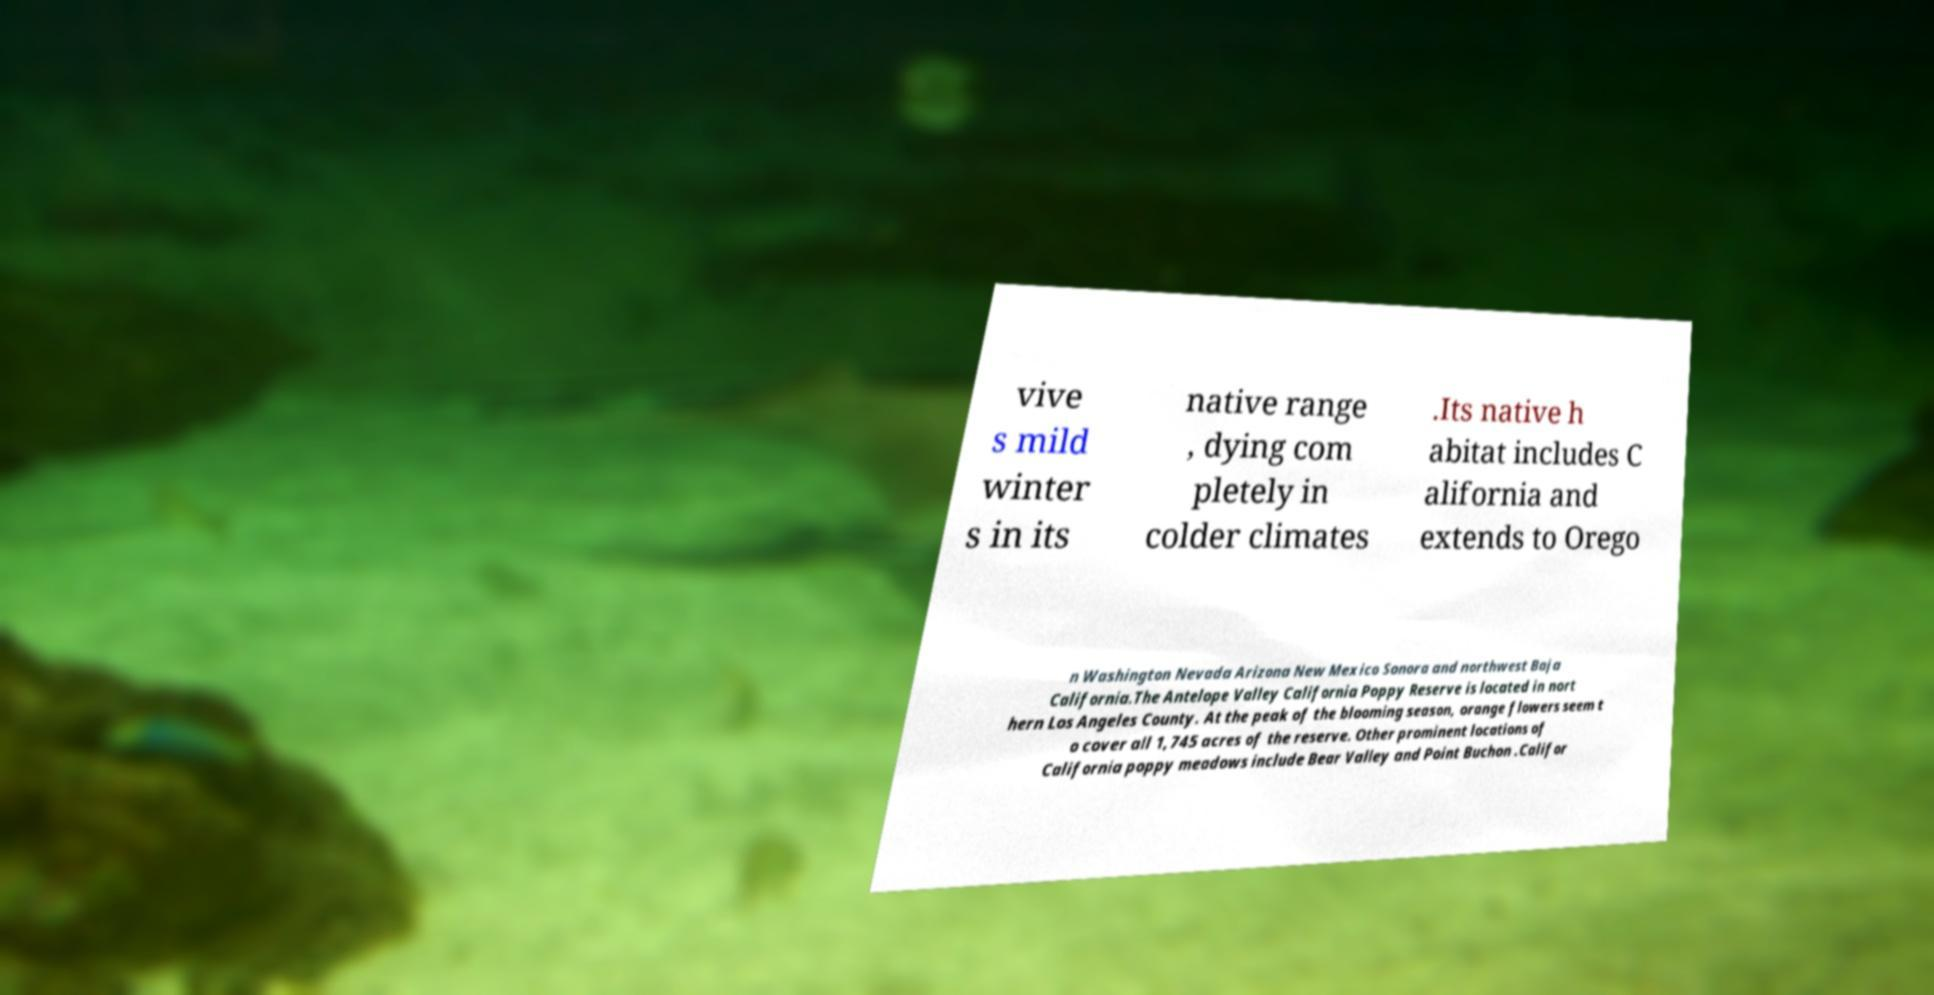There's text embedded in this image that I need extracted. Can you transcribe it verbatim? vive s mild winter s in its native range , dying com pletely in colder climates .Its native h abitat includes C alifornia and extends to Orego n Washington Nevada Arizona New Mexico Sonora and northwest Baja California.The Antelope Valley California Poppy Reserve is located in nort hern Los Angeles County. At the peak of the blooming season, orange flowers seem t o cover all 1,745 acres of the reserve. Other prominent locations of California poppy meadows include Bear Valley and Point Buchon .Califor 